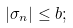<formula> <loc_0><loc_0><loc_500><loc_500>\left | \sigma _ { n } \right | \leq b ;</formula> 